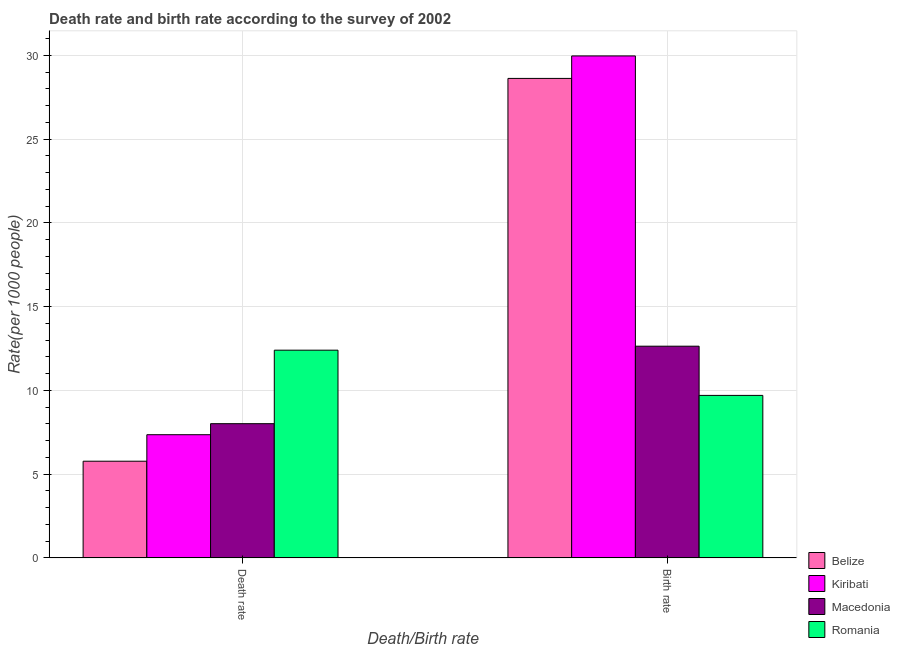How many groups of bars are there?
Keep it short and to the point. 2. How many bars are there on the 1st tick from the left?
Ensure brevity in your answer.  4. What is the label of the 2nd group of bars from the left?
Keep it short and to the point. Birth rate. Across all countries, what is the maximum birth rate?
Keep it short and to the point. 29.96. In which country was the birth rate maximum?
Provide a short and direct response. Kiribati. In which country was the death rate minimum?
Your answer should be very brief. Belize. What is the total death rate in the graph?
Your answer should be compact. 33.54. What is the difference between the death rate in Belize and that in Macedonia?
Provide a succinct answer. -2.24. What is the difference between the death rate in Macedonia and the birth rate in Romania?
Keep it short and to the point. -1.69. What is the average death rate per country?
Keep it short and to the point. 8.38. What is the difference between the death rate and birth rate in Kiribati?
Provide a short and direct response. -22.61. In how many countries, is the death rate greater than 28 ?
Provide a succinct answer. 0. What is the ratio of the birth rate in Romania to that in Kiribati?
Provide a succinct answer. 0.32. In how many countries, is the death rate greater than the average death rate taken over all countries?
Your response must be concise. 1. What does the 1st bar from the left in Birth rate represents?
Offer a terse response. Belize. What does the 1st bar from the right in Birth rate represents?
Your answer should be very brief. Romania. How many bars are there?
Make the answer very short. 8. Are all the bars in the graph horizontal?
Ensure brevity in your answer.  No. What is the difference between two consecutive major ticks on the Y-axis?
Your answer should be compact. 5. Are the values on the major ticks of Y-axis written in scientific E-notation?
Offer a terse response. No. Does the graph contain any zero values?
Provide a succinct answer. No. Does the graph contain grids?
Provide a succinct answer. Yes. Where does the legend appear in the graph?
Make the answer very short. Bottom right. How many legend labels are there?
Provide a succinct answer. 4. How are the legend labels stacked?
Your answer should be very brief. Vertical. What is the title of the graph?
Your answer should be very brief. Death rate and birth rate according to the survey of 2002. Does "United States" appear as one of the legend labels in the graph?
Keep it short and to the point. No. What is the label or title of the X-axis?
Provide a succinct answer. Death/Birth rate. What is the label or title of the Y-axis?
Your response must be concise. Rate(per 1000 people). What is the Rate(per 1000 people) of Belize in Death rate?
Give a very brief answer. 5.77. What is the Rate(per 1000 people) in Kiribati in Death rate?
Offer a terse response. 7.35. What is the Rate(per 1000 people) in Macedonia in Death rate?
Your answer should be compact. 8.01. What is the Rate(per 1000 people) in Belize in Birth rate?
Provide a succinct answer. 28.62. What is the Rate(per 1000 people) of Kiribati in Birth rate?
Offer a very short reply. 29.96. What is the Rate(per 1000 people) in Macedonia in Birth rate?
Ensure brevity in your answer.  12.64. What is the Rate(per 1000 people) in Romania in Birth rate?
Keep it short and to the point. 9.7. Across all Death/Birth rate, what is the maximum Rate(per 1000 people) in Belize?
Ensure brevity in your answer.  28.62. Across all Death/Birth rate, what is the maximum Rate(per 1000 people) of Kiribati?
Keep it short and to the point. 29.96. Across all Death/Birth rate, what is the maximum Rate(per 1000 people) in Macedonia?
Your answer should be compact. 12.64. Across all Death/Birth rate, what is the maximum Rate(per 1000 people) of Romania?
Ensure brevity in your answer.  12.4. Across all Death/Birth rate, what is the minimum Rate(per 1000 people) of Belize?
Give a very brief answer. 5.77. Across all Death/Birth rate, what is the minimum Rate(per 1000 people) in Kiribati?
Your response must be concise. 7.35. Across all Death/Birth rate, what is the minimum Rate(per 1000 people) of Macedonia?
Your answer should be compact. 8.01. Across all Death/Birth rate, what is the minimum Rate(per 1000 people) of Romania?
Keep it short and to the point. 9.7. What is the total Rate(per 1000 people) in Belize in the graph?
Offer a terse response. 34.39. What is the total Rate(per 1000 people) of Kiribati in the graph?
Offer a terse response. 37.32. What is the total Rate(per 1000 people) in Macedonia in the graph?
Your answer should be compact. 20.65. What is the total Rate(per 1000 people) in Romania in the graph?
Ensure brevity in your answer.  22.1. What is the difference between the Rate(per 1000 people) in Belize in Death rate and that in Birth rate?
Your answer should be very brief. -22.85. What is the difference between the Rate(per 1000 people) in Kiribati in Death rate and that in Birth rate?
Your answer should be very brief. -22.61. What is the difference between the Rate(per 1000 people) of Macedonia in Death rate and that in Birth rate?
Offer a terse response. -4.62. What is the difference between the Rate(per 1000 people) of Belize in Death rate and the Rate(per 1000 people) of Kiribati in Birth rate?
Make the answer very short. -24.19. What is the difference between the Rate(per 1000 people) in Belize in Death rate and the Rate(per 1000 people) in Macedonia in Birth rate?
Give a very brief answer. -6.87. What is the difference between the Rate(per 1000 people) of Belize in Death rate and the Rate(per 1000 people) of Romania in Birth rate?
Provide a short and direct response. -3.93. What is the difference between the Rate(per 1000 people) of Kiribati in Death rate and the Rate(per 1000 people) of Macedonia in Birth rate?
Keep it short and to the point. -5.28. What is the difference between the Rate(per 1000 people) in Kiribati in Death rate and the Rate(per 1000 people) in Romania in Birth rate?
Ensure brevity in your answer.  -2.35. What is the difference between the Rate(per 1000 people) in Macedonia in Death rate and the Rate(per 1000 people) in Romania in Birth rate?
Make the answer very short. -1.69. What is the average Rate(per 1000 people) of Belize per Death/Birth rate?
Make the answer very short. 17.2. What is the average Rate(per 1000 people) in Kiribati per Death/Birth rate?
Your response must be concise. 18.66. What is the average Rate(per 1000 people) in Macedonia per Death/Birth rate?
Your response must be concise. 10.32. What is the average Rate(per 1000 people) of Romania per Death/Birth rate?
Offer a very short reply. 11.05. What is the difference between the Rate(per 1000 people) of Belize and Rate(per 1000 people) of Kiribati in Death rate?
Offer a terse response. -1.58. What is the difference between the Rate(per 1000 people) of Belize and Rate(per 1000 people) of Macedonia in Death rate?
Your answer should be compact. -2.24. What is the difference between the Rate(per 1000 people) in Belize and Rate(per 1000 people) in Romania in Death rate?
Your answer should be compact. -6.63. What is the difference between the Rate(per 1000 people) of Kiribati and Rate(per 1000 people) of Macedonia in Death rate?
Your response must be concise. -0.66. What is the difference between the Rate(per 1000 people) in Kiribati and Rate(per 1000 people) in Romania in Death rate?
Offer a very short reply. -5.05. What is the difference between the Rate(per 1000 people) of Macedonia and Rate(per 1000 people) of Romania in Death rate?
Provide a succinct answer. -4.39. What is the difference between the Rate(per 1000 people) of Belize and Rate(per 1000 people) of Kiribati in Birth rate?
Make the answer very short. -1.34. What is the difference between the Rate(per 1000 people) of Belize and Rate(per 1000 people) of Macedonia in Birth rate?
Provide a short and direct response. 15.98. What is the difference between the Rate(per 1000 people) in Belize and Rate(per 1000 people) in Romania in Birth rate?
Offer a very short reply. 18.92. What is the difference between the Rate(per 1000 people) of Kiribati and Rate(per 1000 people) of Macedonia in Birth rate?
Your answer should be very brief. 17.33. What is the difference between the Rate(per 1000 people) of Kiribati and Rate(per 1000 people) of Romania in Birth rate?
Ensure brevity in your answer.  20.27. What is the difference between the Rate(per 1000 people) of Macedonia and Rate(per 1000 people) of Romania in Birth rate?
Provide a short and direct response. 2.94. What is the ratio of the Rate(per 1000 people) of Belize in Death rate to that in Birth rate?
Offer a very short reply. 0.2. What is the ratio of the Rate(per 1000 people) in Kiribati in Death rate to that in Birth rate?
Ensure brevity in your answer.  0.25. What is the ratio of the Rate(per 1000 people) of Macedonia in Death rate to that in Birth rate?
Offer a very short reply. 0.63. What is the ratio of the Rate(per 1000 people) in Romania in Death rate to that in Birth rate?
Make the answer very short. 1.28. What is the difference between the highest and the second highest Rate(per 1000 people) of Belize?
Make the answer very short. 22.85. What is the difference between the highest and the second highest Rate(per 1000 people) of Kiribati?
Provide a succinct answer. 22.61. What is the difference between the highest and the second highest Rate(per 1000 people) of Macedonia?
Your response must be concise. 4.62. What is the difference between the highest and the lowest Rate(per 1000 people) in Belize?
Make the answer very short. 22.85. What is the difference between the highest and the lowest Rate(per 1000 people) of Kiribati?
Provide a succinct answer. 22.61. What is the difference between the highest and the lowest Rate(per 1000 people) of Macedonia?
Your answer should be compact. 4.62. What is the difference between the highest and the lowest Rate(per 1000 people) of Romania?
Your answer should be compact. 2.7. 